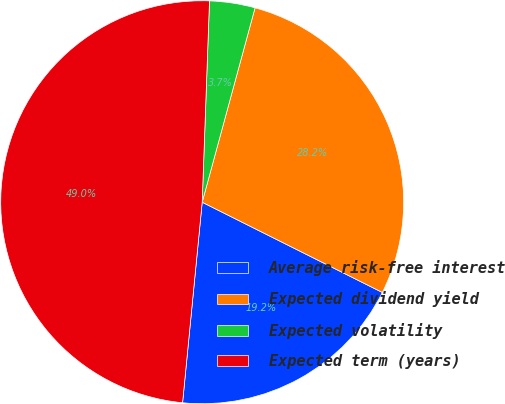Convert chart. <chart><loc_0><loc_0><loc_500><loc_500><pie_chart><fcel>Average risk-free interest<fcel>Expected dividend yield<fcel>Expected volatility<fcel>Expected term (years)<nl><fcel>19.16%<fcel>28.16%<fcel>3.65%<fcel>49.02%<nl></chart> 